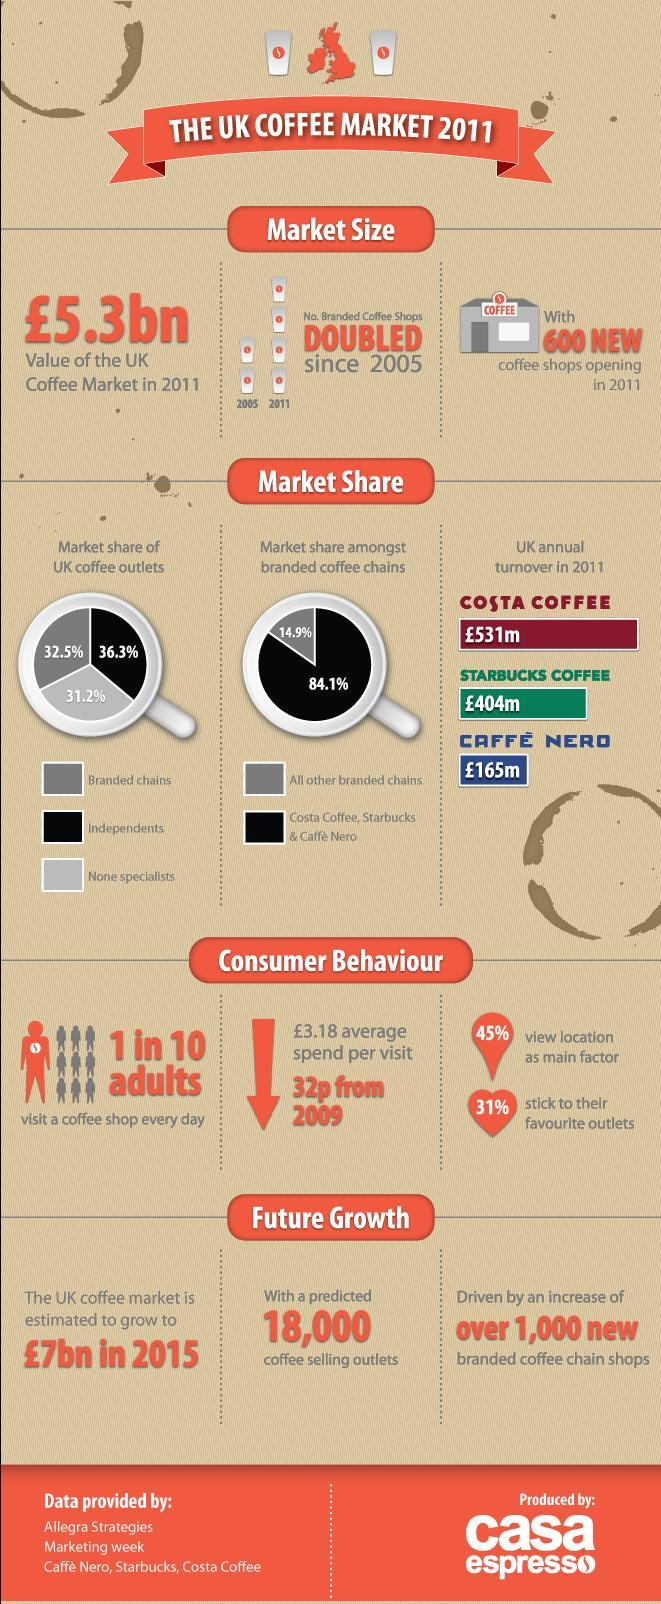Among Costa Coffee, Starbucks Coffee and Caffe Nero, which one is second in terms of annual turnovers as of 2011?
Answer the question with a short phrase. STARBUCKS COFFEE Which branded chains have the largest market share? COSTA COFFEE, STARBUCKS COFFEE, CAFFE NERO What percent of UK coffee outlets are independents? 36.3% 